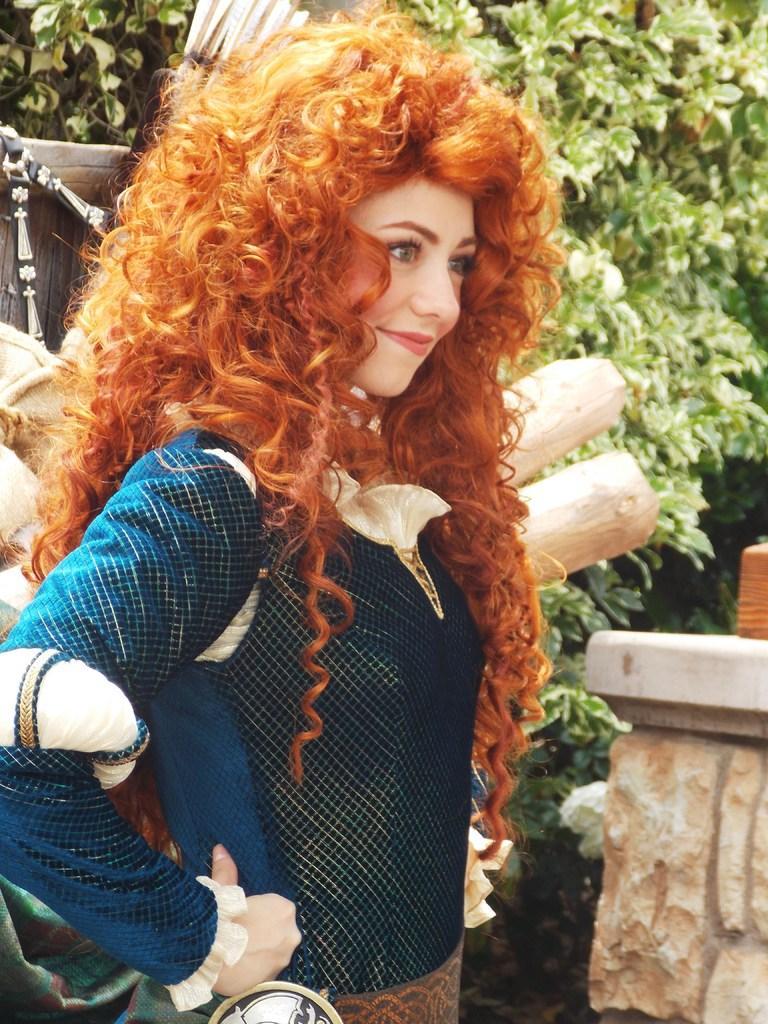Could you give a brief overview of what you see in this image? In this image I can see there is a woman standing and is smiling, there are few wooden sticks placed and there is a plant with leaves. 